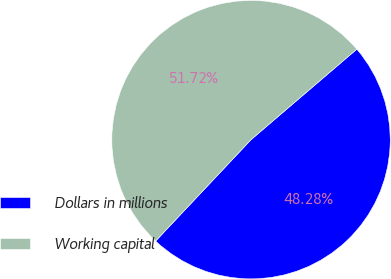<chart> <loc_0><loc_0><loc_500><loc_500><pie_chart><fcel>Dollars in millions<fcel>Working capital<nl><fcel>48.28%<fcel>51.72%<nl></chart> 